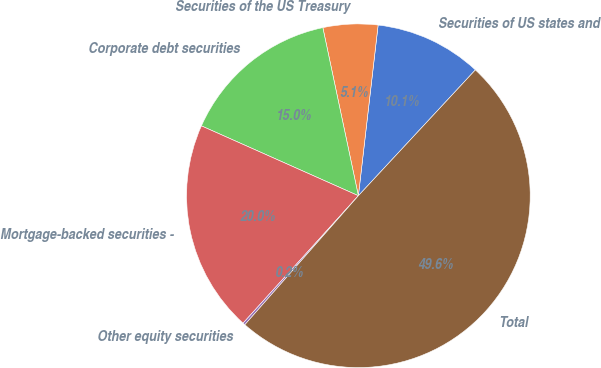<chart> <loc_0><loc_0><loc_500><loc_500><pie_chart><fcel>Securities of US states and<fcel>Securities of the US Treasury<fcel>Corporate debt securities<fcel>Mortgage-backed securities -<fcel>Other equity securities<fcel>Total<nl><fcel>10.09%<fcel>5.15%<fcel>15.02%<fcel>19.96%<fcel>0.22%<fcel>49.57%<nl></chart> 